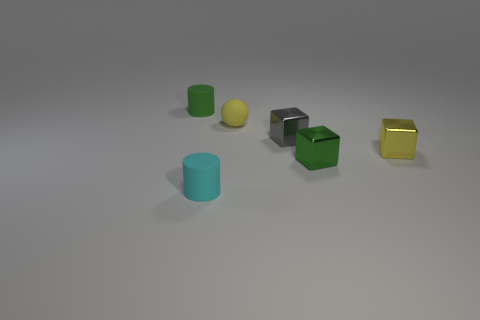Subtract all yellow cylinders. Subtract all purple spheres. How many cylinders are left? 2 Add 3 small green cylinders. How many objects exist? 9 Subtract all spheres. How many objects are left? 5 Add 5 yellow metallic cubes. How many yellow metallic cubes are left? 6 Add 3 small green matte objects. How many small green matte objects exist? 4 Subtract 0 purple blocks. How many objects are left? 6 Subtract all gray metal blocks. Subtract all tiny purple things. How many objects are left? 5 